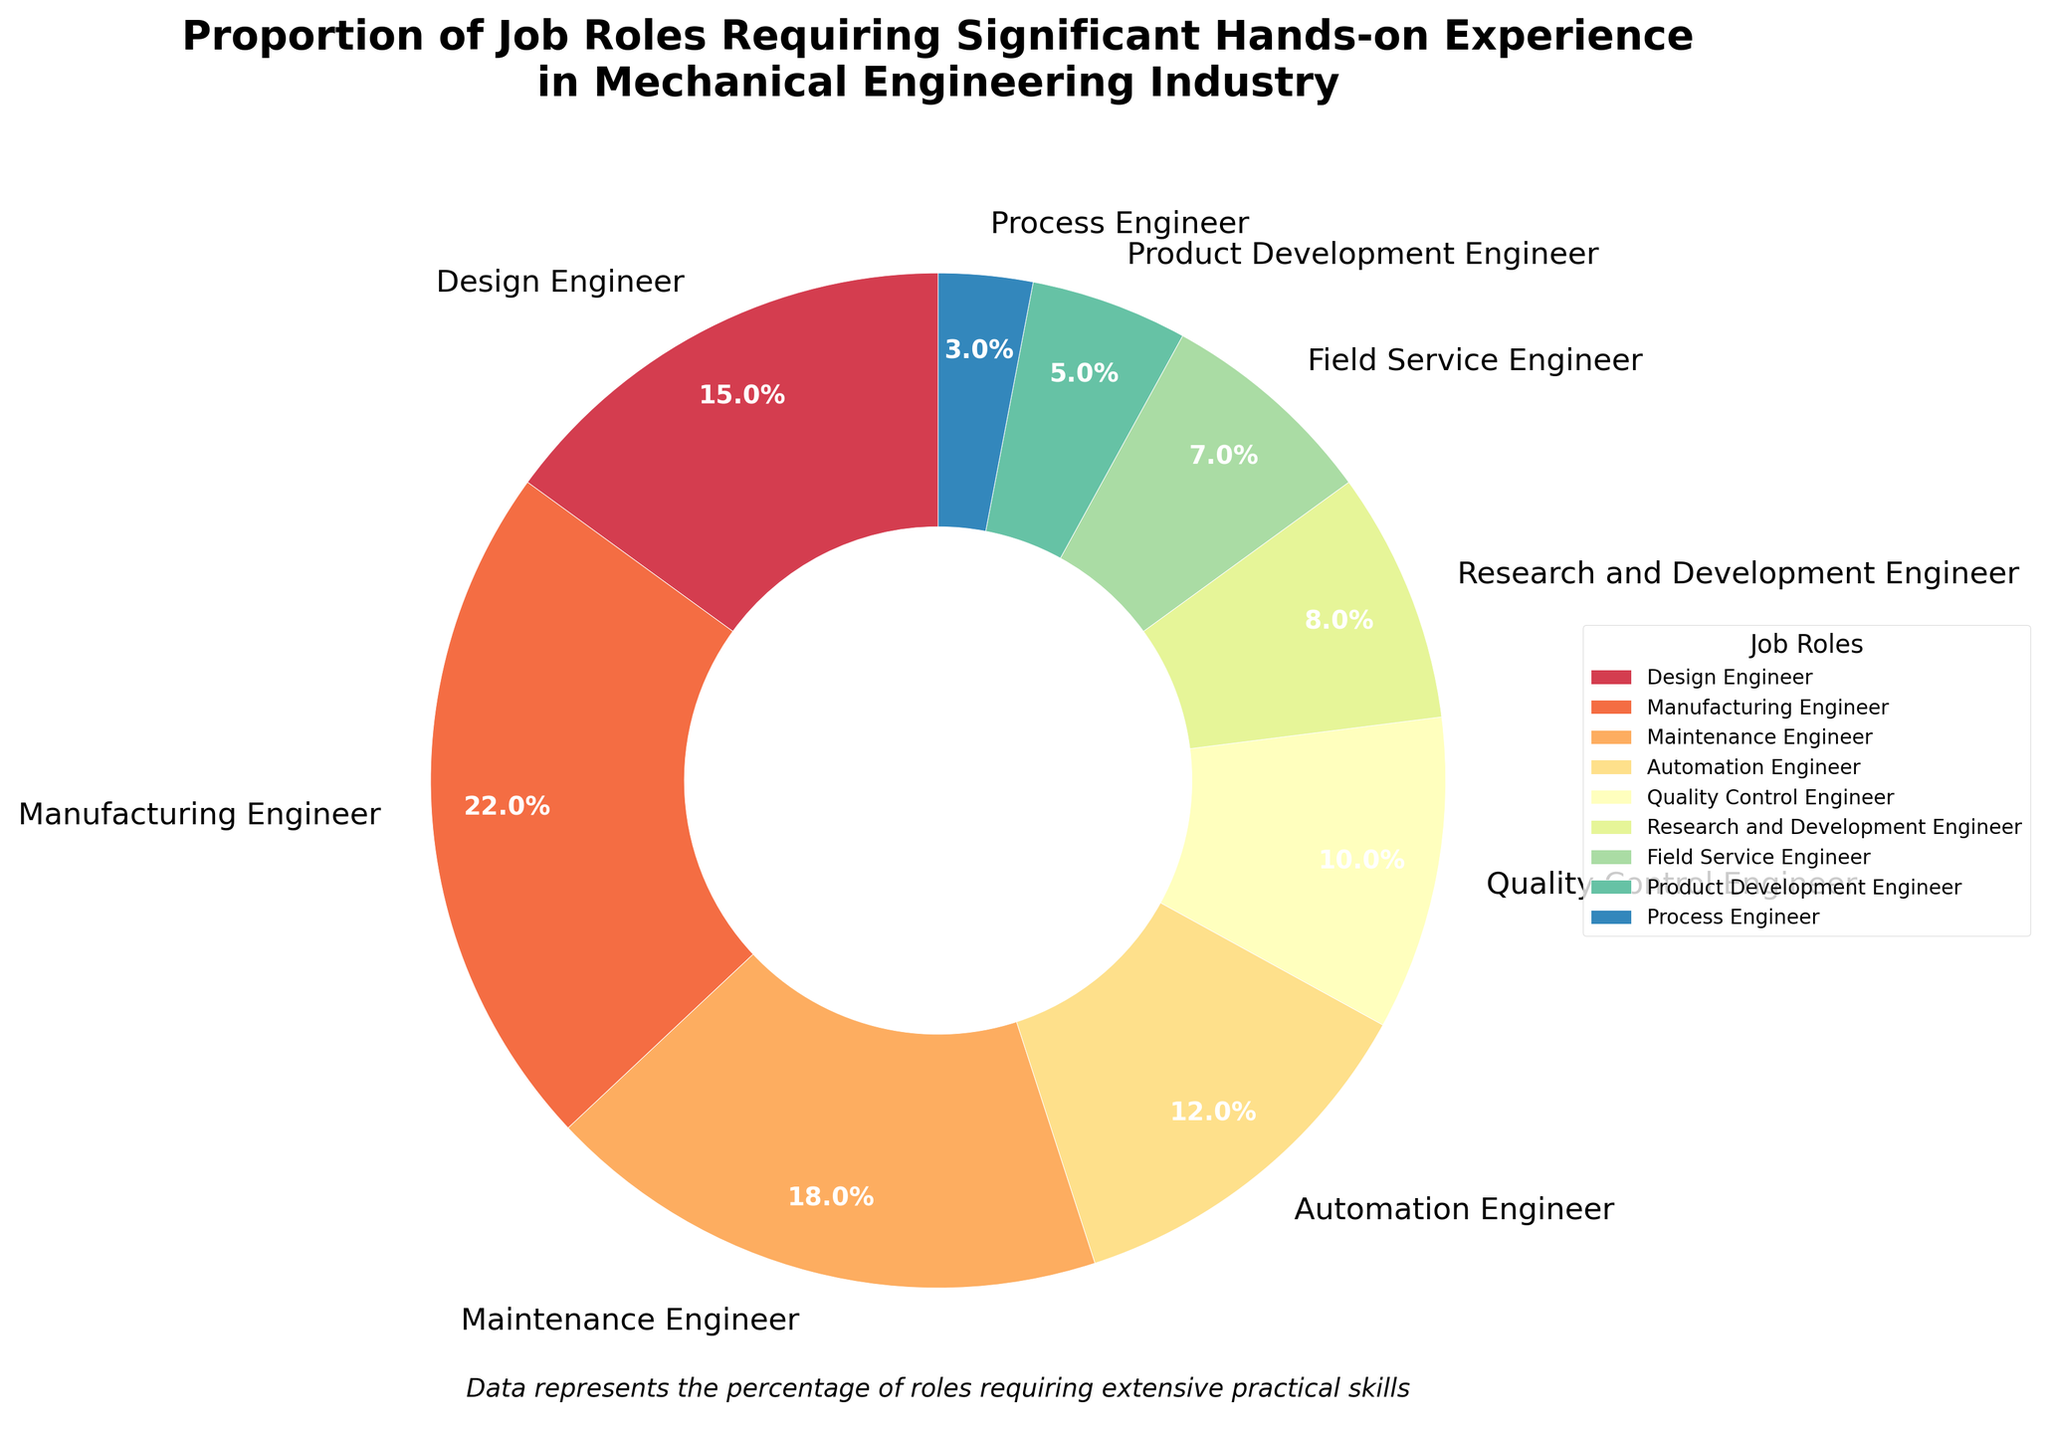What's the job role with the highest percentage requiring significant hands-on experience? The job role with the highest percentage can be identified as the point with the largest segment in the pie chart. By looking at the segments, we find that the largest segment corresponds to the Manufacturing Engineer.
Answer: Manufacturing Engineer What is the combined proportion of Design Engineers and Quality Control Engineers? To find the combined proportion, sum the percentages of the Design Engineers (15%) and Quality Control Engineers (10%). The result is 15% + 10% = 25%.
Answer: 25% Which job roles have a higher proportion of hands-on experience requirements than Automation Engineer? First, identify the percentage of hands-on experience required by an Automation Engineer, which is 12%. Compare that with other roles: Design Engineer (15%), Manufacturing Engineer (22%), Maintenance Engineer (18%). These have higher proportions.
Answer: Design Engineer, Manufacturing Engineer, Maintenance Engineer What is the difference in percentage between Manufacturing Engineers and Field Service Engineers? Subtract the percentage of Field Service Engineers (7%) from that of Manufacturing Engineers (22%). The result is 22% - 7% = 15%.
Answer: 15% What percentage of roles have less than 10% hands-on experience requirements? Identify job roles with less than 10% and sum their percentages: Research and Development Engineer (8%), Field Service Engineer (7%), Product Development Engineer (5%), Process Engineer (3%). The total is 8% + 7% + 5% + 3% = 23%.
Answer: 23% Which job role is represented by the smallest segment in the pie chart, and what is its percentage? Examine the segments visually to find the smallest one, corresponding to the Process Engineer, which has a percentage of 3%.
Answer: Process Engineer, 3% If Quality Control Engineers and Maintenance Engineers are combined, what would their combined percentage be? Add the percentages of Quality Control Engineers (10%) and Maintenance Engineers (18%). The total is 10% + 18% = 28%.
Answer: 28% Which job role has a similar percentage to that of the Quality Control Engineer? Compare the percentage of Quality Control Engineer (10%) with other roles. The Research and Development Engineer has a slightly lower percentage at 8%, which is the closest.
Answer: Research and Development Engineer What is the average proportion of hands-on experience requirement for the roles of Automation Engineer, Field Service Engineer, and Product Development Engineer? Sum the percentages of Automation Engineer (12%), Field Service Engineer (7%), and Product Development Engineer (5%). Then divide by 3 roles. The total is 12% + 7% + 5% = 24%, and the average is 24% / 3 = 8%.
Answer: 8% How do the proportions of Maintenance Engineers and Design Engineers compare to each other? The Maintenance Engineer has a proportion of 18%, while the Design Engineer has 15%. Maintenance Engineer has a higher percentage.
Answer: Maintenance Engineer has a higher percentage 